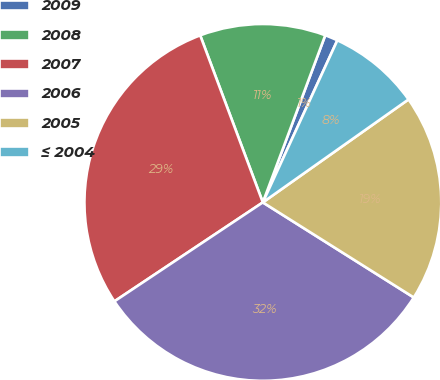Convert chart. <chart><loc_0><loc_0><loc_500><loc_500><pie_chart><fcel>2009<fcel>2008<fcel>2007<fcel>2006<fcel>2005<fcel>≤ 2004<nl><fcel>1.17%<fcel>11.4%<fcel>28.65%<fcel>31.7%<fcel>18.74%<fcel>8.35%<nl></chart> 